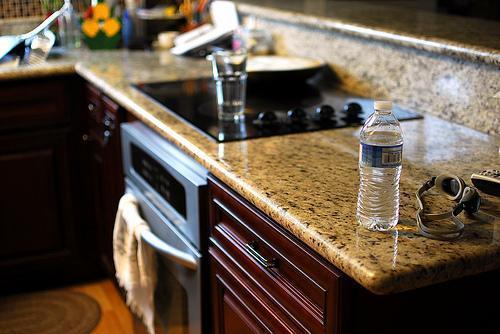How many goggles are in this picture?
Give a very brief answer. 1. 